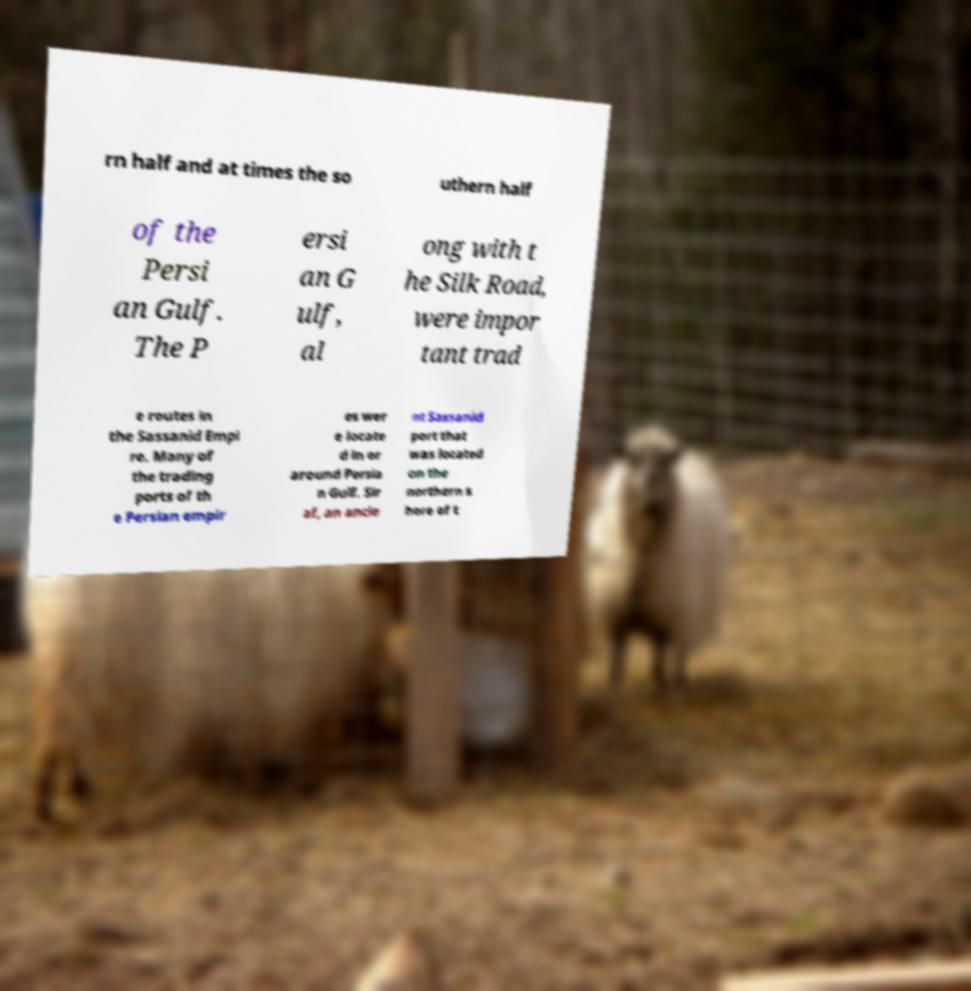What messages or text are displayed in this image? I need them in a readable, typed format. rn half and at times the so uthern half of the Persi an Gulf. The P ersi an G ulf, al ong with t he Silk Road, were impor tant trad e routes in the Sassanid Empi re. Many of the trading ports of th e Persian empir es wer e locate d in or around Persia n Gulf. Sir af, an ancie nt Sassanid port that was located on the northern s hore of t 